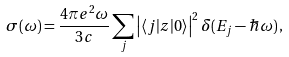Convert formula to latex. <formula><loc_0><loc_0><loc_500><loc_500>\sigma ( \omega ) = \frac { 4 \pi e ^ { 2 } \omega } { 3 c } \sum _ { j } \left | \langle j | z | 0 \rangle \right | ^ { 2 } \delta ( E _ { j } - \hbar { \omega } ) \, ,</formula> 